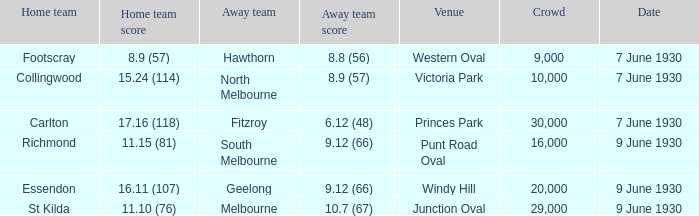What away team played Footscray? Hawthorn. 